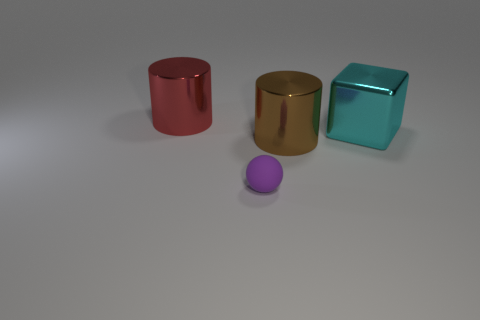Subtract all green blocks. Subtract all red balls. How many blocks are left? 1 Add 3 tiny green matte cylinders. How many objects exist? 7 Subtract all blocks. How many objects are left? 3 Subtract 0 purple cylinders. How many objects are left? 4 Subtract all brown objects. Subtract all big cyan matte cubes. How many objects are left? 3 Add 1 brown things. How many brown things are left? 2 Add 2 big blue shiny cubes. How many big blue shiny cubes exist? 2 